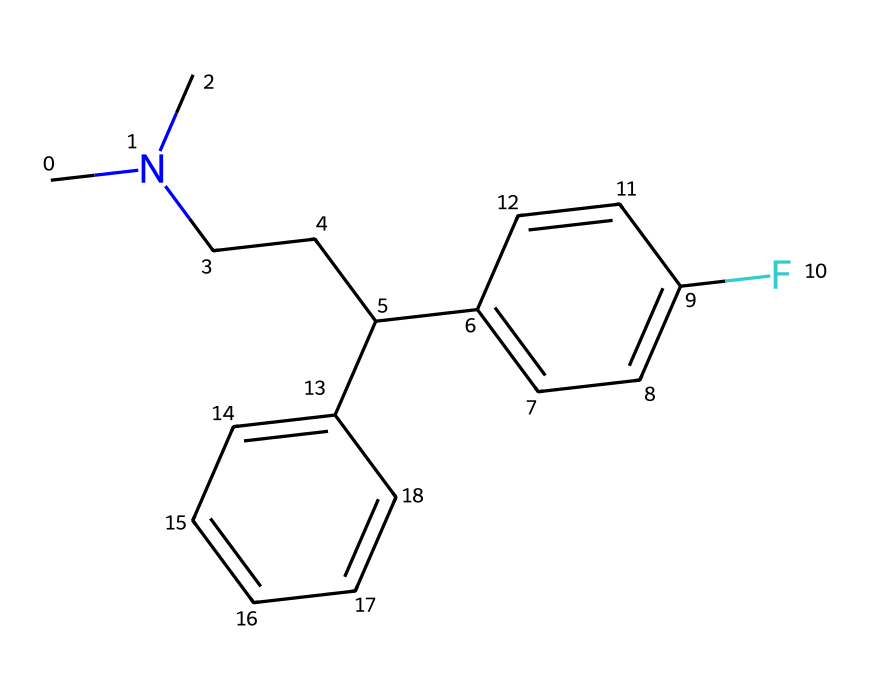What is the main functional group in this chemical? The chemical contains a tertiary amine, indicated by the nitrogen atom bonded to three carbon groups. This is characteristic of amines.
Answer: tertiary amine How many carbon atoms are present in this molecule? By counting each carbon in the structure, including those in the rings and the side chains, we find there are 18 carbon atoms.
Answer: 18 What type of bonding primarily holds this molecule together? The majority of this molecule is held together by covalent bonds, which occur between atoms sharing electrons, specifically in the carbon and nitrogen connections.
Answer: covalent bonds Is this molecule likely to be polar or nonpolar? Considering the presence of the nitrogen atom and the absence of highly electronegative atoms like oxygen in significant amounts along with the overall structure, it suggests this molecule is more nonpolar than polar.
Answer: nonpolar What is the significance of the fluorine substituent in this drug? The fluorine group is an electron-withdrawing substituent, which can enhance the pharmacological effects of the drug by affecting its electronic properties and interaction with biological targets.
Answer: enhances pharmacological effects How many aromatic rings are present in this structure? In analyzing the chemical structure, there are two distinct aromatic rings (the two phenyl groups) present in the molecule, which contributes to its overall stability and reactivity.
Answer: 2 